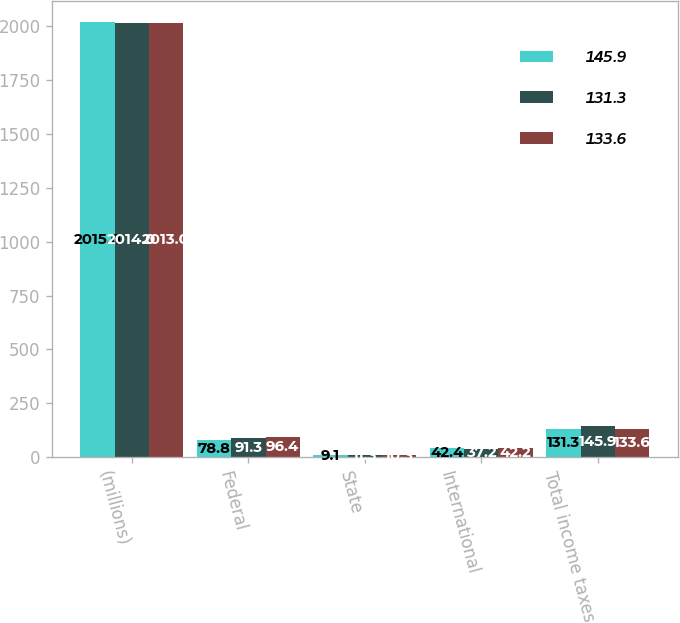<chart> <loc_0><loc_0><loc_500><loc_500><stacked_bar_chart><ecel><fcel>(millions)<fcel>Federal<fcel>State<fcel>International<fcel>Total income taxes<nl><fcel>145.9<fcel>2015<fcel>78.8<fcel>9.1<fcel>42.4<fcel>131.3<nl><fcel>131.3<fcel>2014<fcel>91.3<fcel>11.3<fcel>37.2<fcel>145.9<nl><fcel>133.6<fcel>2013<fcel>96.4<fcel>10.3<fcel>42.2<fcel>133.6<nl></chart> 